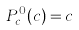Convert formula to latex. <formula><loc_0><loc_0><loc_500><loc_500>P _ { c } ^ { 0 } ( c ) = c</formula> 